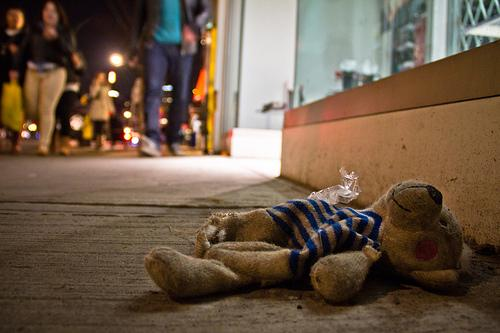What kind of environment is the image set in, and what details support that? The image is set in a city environment at night, with details such as rough concrete sidewalk, street lights, city lights, and store entrance, pavement suggesting an urban setting. How many teddy bear captions are associated with the image? There are no teddy bear captions associated with the image. Identify the actions of the various people in the image. The people in the image are walking on the sidewalk. What are the main colors visible in the clothing items in the image? The main colors visible in the clothing items are blue, black, and white. Describe the condition and appearance of the teddy bear. The teddy bear is ripped and missing its stuffing with blue stripes and red cheeks, appearing flat and torn apart. Describe the texture of the ground where the bear is positioned. The ground has a rough concrete texture that seems to be a part of the sidewalk. List the main objects in the image. The main objects in the image are a teddy bear, people walking, sidewalk, and store front. What types of objects are located in the upper part of the image? The upper part of the image includes street lights and the night sky. Explain the picture sentiment using a sentence. The scene conveys a sad and tense feeling with the ripped teddy bear on the street at night and people walking around it. What kind of clothing items can be found on the people in the image? The clothing items visible on the people in the image include blue jeans and a black jacket. Can you spot the green bicycle leaning against the building? There is no green bicycle visible in the image. Is there a policeman patrolling the street? There is no policeman visible in the image. Do you notice a large clock tower in the background? There is no clock tower visible in the image. Is there an umbrella in the store window? There is no umbrella visible in the store window. Can you find a yellow street sign near the sidewalk? There is no yellow street sign near the sidewalk. Do you see the cat sitting on the roof of the store? There is no cat visible on the roof of the store. 